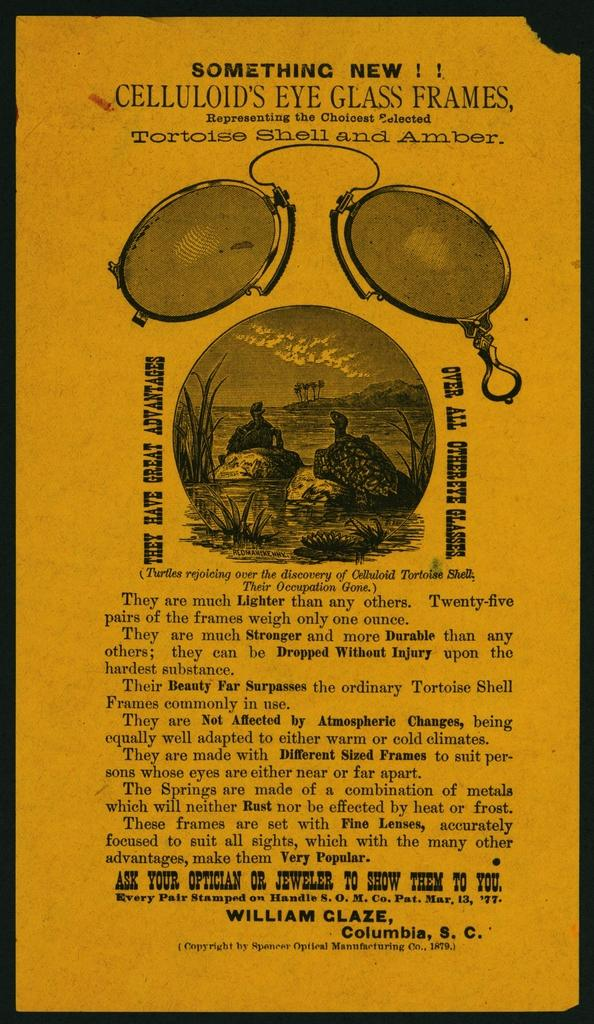<image>
Summarize the visual content of the image. Poster showing two turtle talking and the words "Something New" on top. 